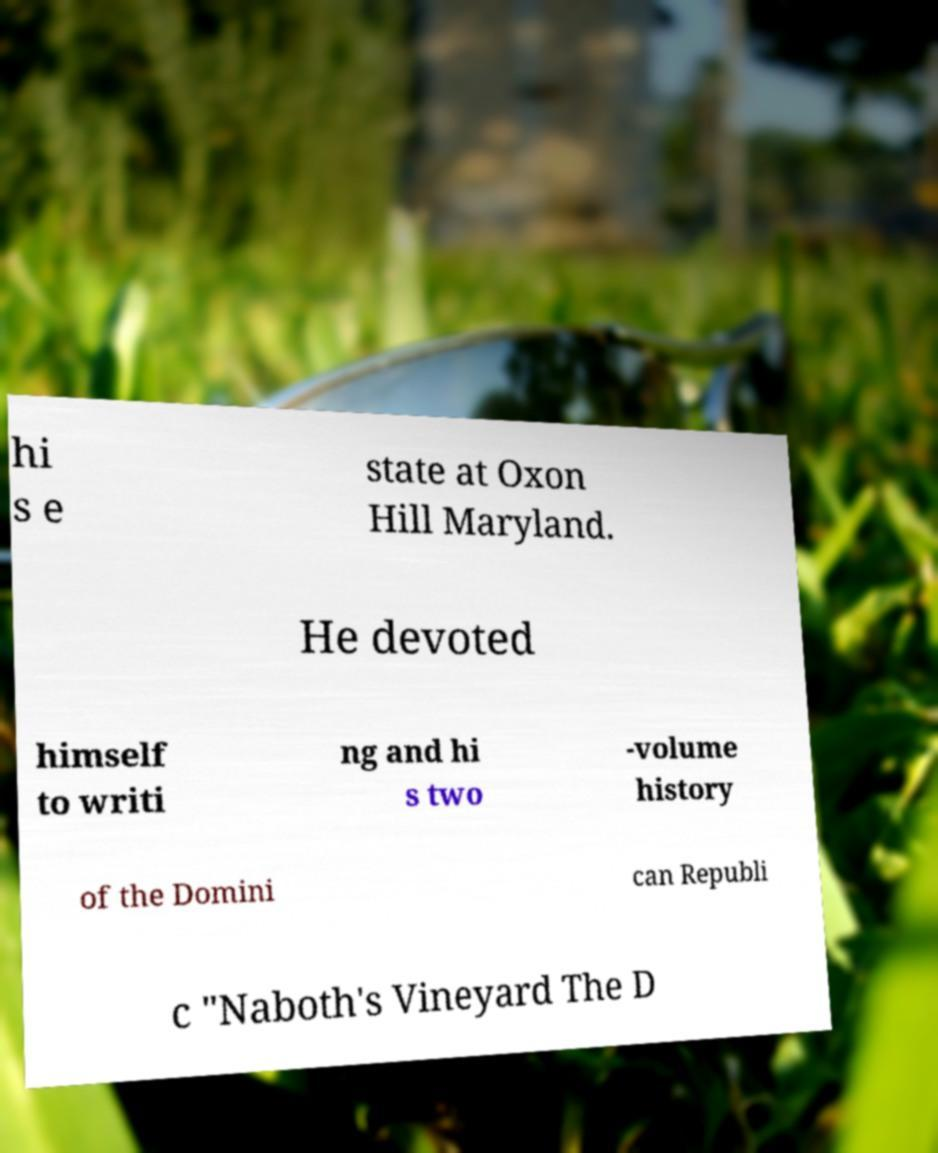Could you assist in decoding the text presented in this image and type it out clearly? hi s e state at Oxon Hill Maryland. He devoted himself to writi ng and hi s two -volume history of the Domini can Republi c "Naboth's Vineyard The D 